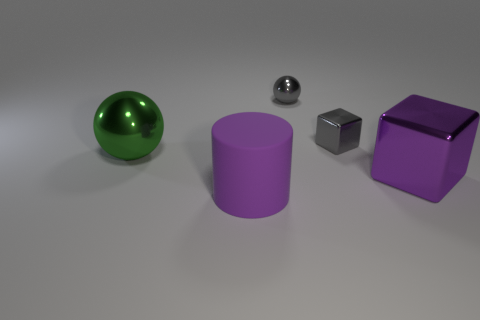Add 3 big purple matte objects. How many objects exist? 8 Subtract all cylinders. How many objects are left? 4 Add 5 large purple matte objects. How many large purple matte objects are left? 6 Add 3 matte cylinders. How many matte cylinders exist? 4 Subtract 0 cyan cylinders. How many objects are left? 5 Subtract all brown metallic cubes. Subtract all small gray metallic balls. How many objects are left? 4 